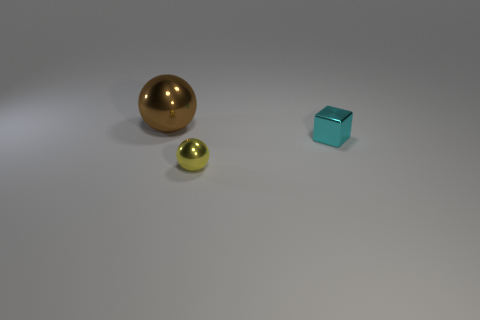What number of tiny brown rubber cubes are there?
Your response must be concise. 0. There is a thing in front of the tiny cyan block; what is its shape?
Ensure brevity in your answer.  Sphere. What number of other objects are the same size as the yellow metallic thing?
Your answer should be compact. 1. Do the tiny thing in front of the small cyan cube and the tiny metal object behind the small yellow ball have the same shape?
Offer a terse response. No. There is a small sphere; how many metal cubes are behind it?
Offer a terse response. 1. What is the color of the sphere that is right of the large metal object?
Provide a short and direct response. Yellow. What is the color of the small object that is the same shape as the big metal thing?
Provide a short and direct response. Yellow. Is there any other thing that is the same color as the metal block?
Give a very brief answer. No. Are there more gray rubber cubes than tiny metal things?
Keep it short and to the point. No. Is the brown object made of the same material as the small yellow thing?
Offer a very short reply. Yes. 